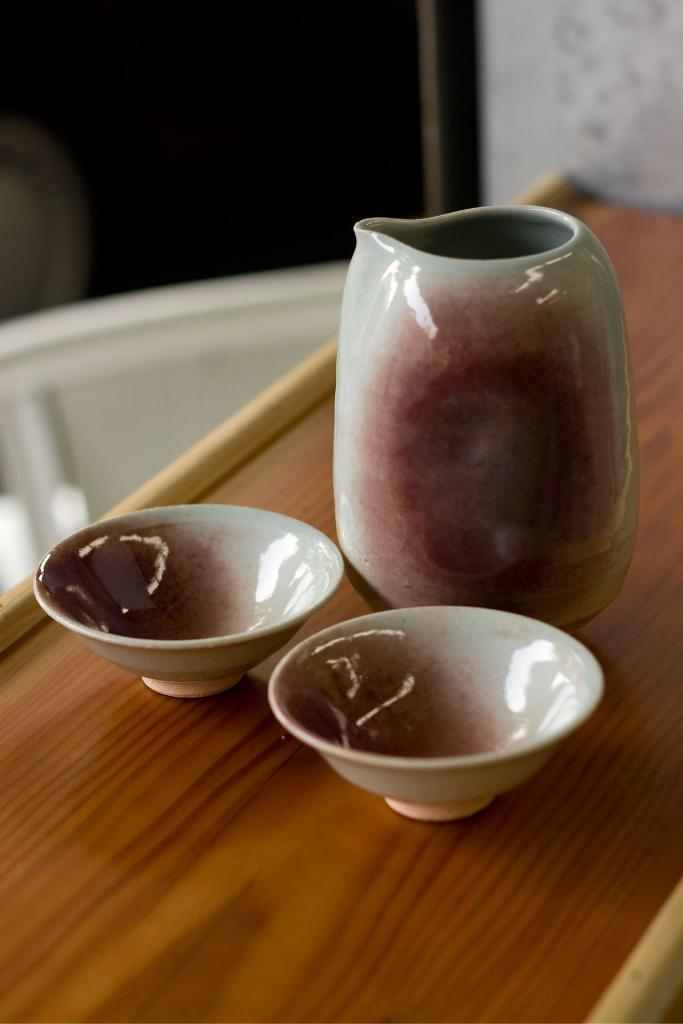What type of container is visible in the image? There is a jar in the image. What other containers can be seen in the image? There are bowls in the image. What material is the surface on which the containers are placed? The wooden surface is present in the image. Can you describe the background of the image? The background of the image is blurred. How many sticks are visible in the image? There are no sticks present in the image. Can you describe the jellyfish in the image? There are no jellyfish present in the image. 